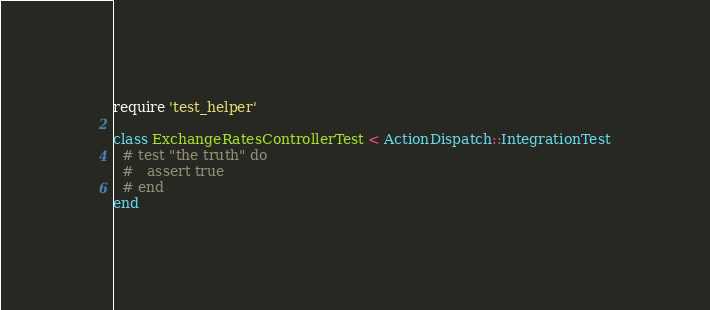Convert code to text. <code><loc_0><loc_0><loc_500><loc_500><_Ruby_>require 'test_helper'

class ExchangeRatesControllerTest < ActionDispatch::IntegrationTest
  # test "the truth" do
  #   assert true
  # end
end
</code> 